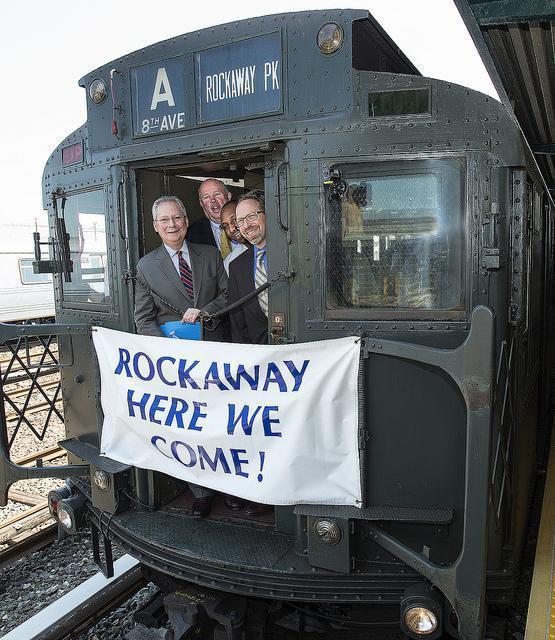Where is this train heading?
Indicate the correct choice and explain in the format: 'Answer: answer
Rationale: rationale.'
Options: 8th avenue, central pk, rockaway, pike ave. Answer: rockaway.
Rationale: The train is going to rockaway. 